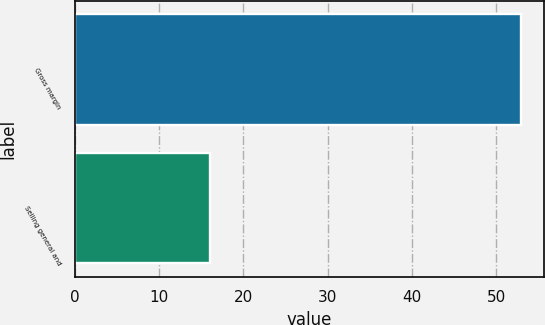<chart> <loc_0><loc_0><loc_500><loc_500><bar_chart><fcel>Gross margin<fcel>Selling general and<nl><fcel>53<fcel>16<nl></chart> 